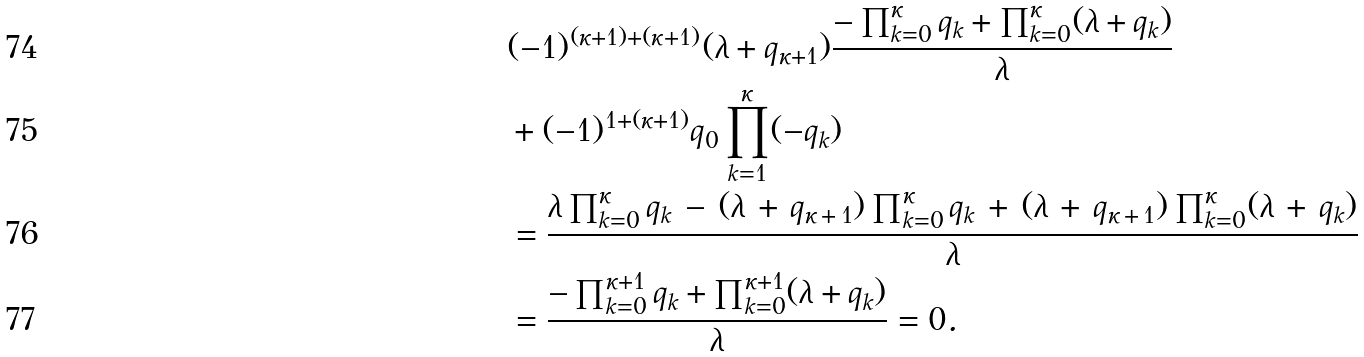Convert formula to latex. <formula><loc_0><loc_0><loc_500><loc_500>& ( - 1 ) ^ { ( \kappa + 1 ) + ( \kappa + 1 ) } ( \lambda + q _ { \kappa + 1 } ) \frac { - \prod _ { k = 0 } ^ { \kappa } q _ { k } + \prod _ { k = 0 } ^ { \kappa } ( \lambda + q _ { k } ) } { \lambda } \\ & + ( - 1 ) ^ { 1 + ( \kappa + 1 ) } q _ { 0 } \prod _ { k = 1 } ^ { \kappa } ( - q _ { k } ) \\ & = \frac { \lambda \prod _ { k = 0 } ^ { \kappa } q _ { k } \, - \, ( \lambda \, + \, q _ { \kappa \, + \, 1 } ) \prod _ { k = 0 } ^ { \kappa } q _ { k } \, + \, ( \lambda \, + \, q _ { \kappa \, + \, 1 } ) \prod _ { k = 0 } ^ { \kappa } ( \lambda \, + \, q _ { k } ) } { \lambda } \\ & = \frac { - \prod _ { k = 0 } ^ { \kappa + 1 } q _ { k } + \prod _ { k = 0 } ^ { \kappa + 1 } ( \lambda + q _ { k } ) } { \lambda } = 0 .</formula> 